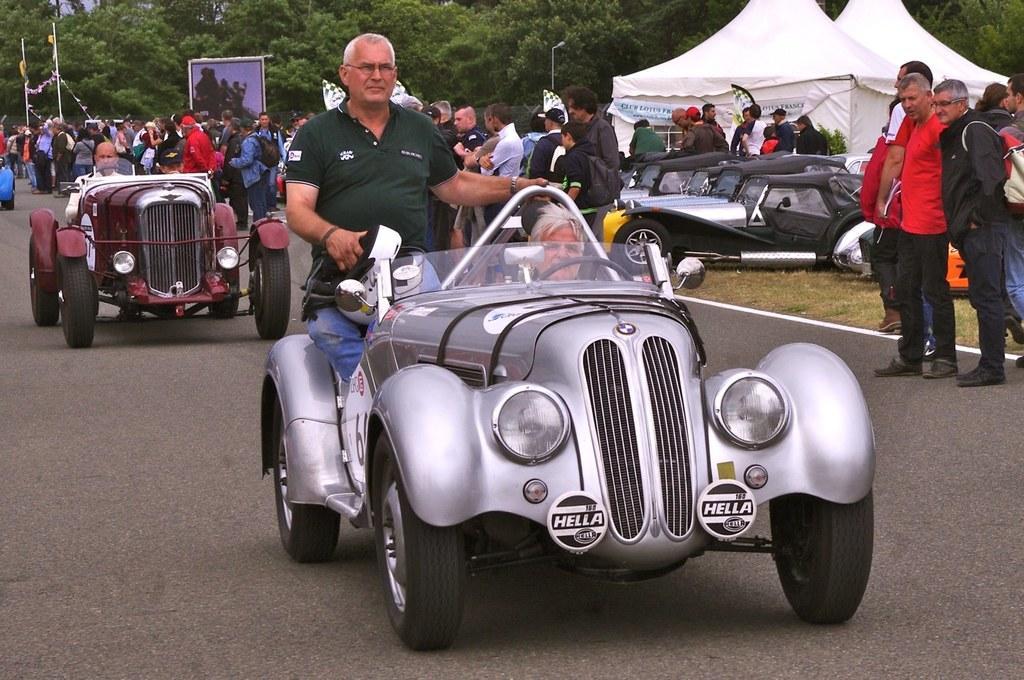Can you describe this image briefly? In the image there is a man on the car and on the backside there is another car and at side there are many people looking at cars on the road. 